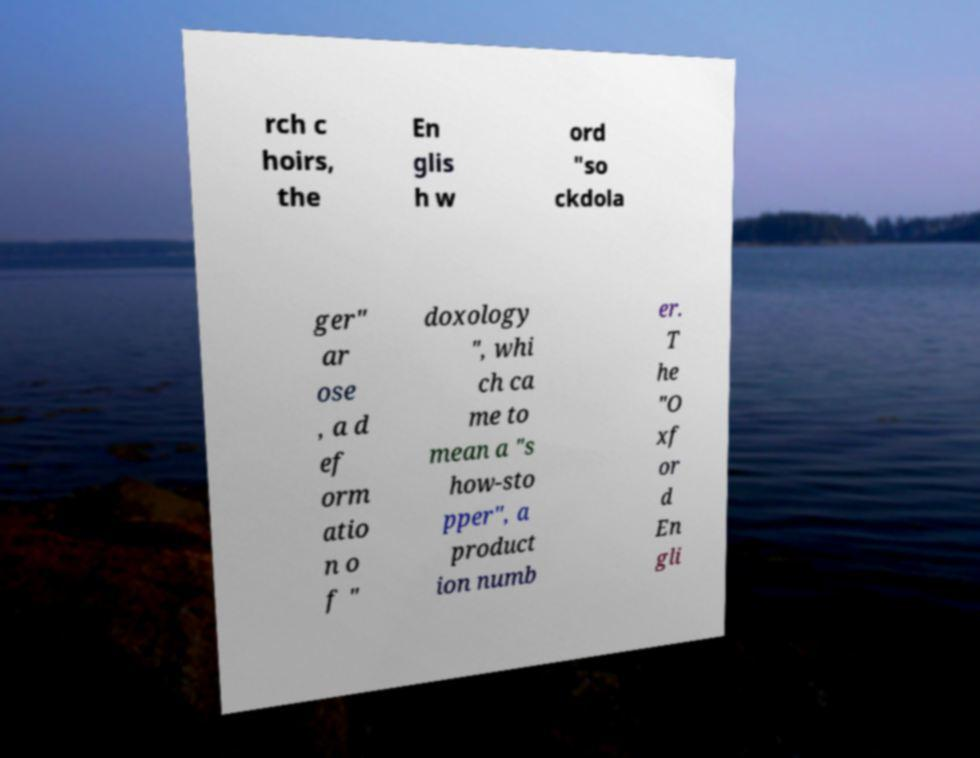What messages or text are displayed in this image? I need them in a readable, typed format. rch c hoirs, the En glis h w ord "so ckdola ger" ar ose , a d ef orm atio n o f " doxology ", whi ch ca me to mean a "s how-sto pper", a product ion numb er. T he "O xf or d En gli 